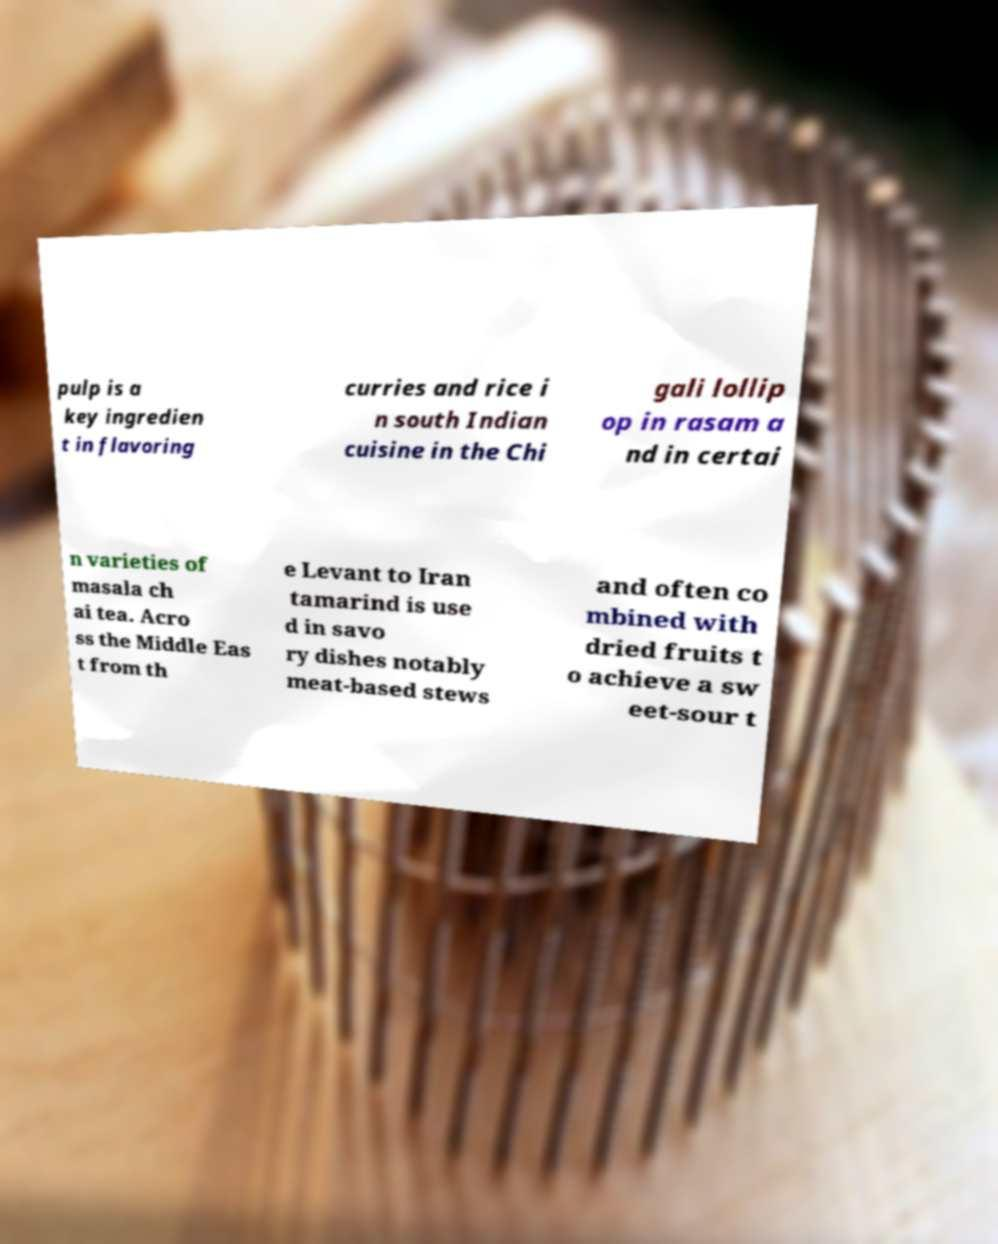Please read and relay the text visible in this image. What does it say? pulp is a key ingredien t in flavoring curries and rice i n south Indian cuisine in the Chi gali lollip op in rasam a nd in certai n varieties of masala ch ai tea. Acro ss the Middle Eas t from th e Levant to Iran tamarind is use d in savo ry dishes notably meat-based stews and often co mbined with dried fruits t o achieve a sw eet-sour t 